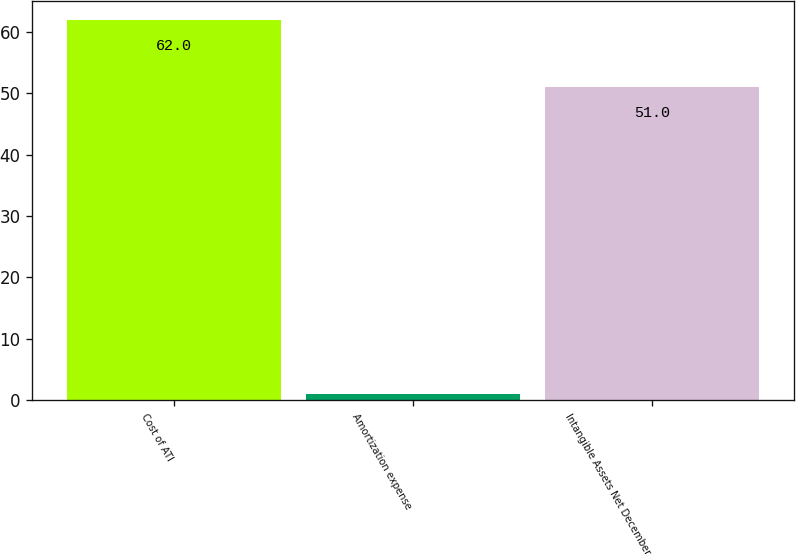Convert chart to OTSL. <chart><loc_0><loc_0><loc_500><loc_500><bar_chart><fcel>Cost of ATI<fcel>Amortization expense<fcel>Intangible Assets Net December<nl><fcel>62<fcel>1<fcel>51<nl></chart> 